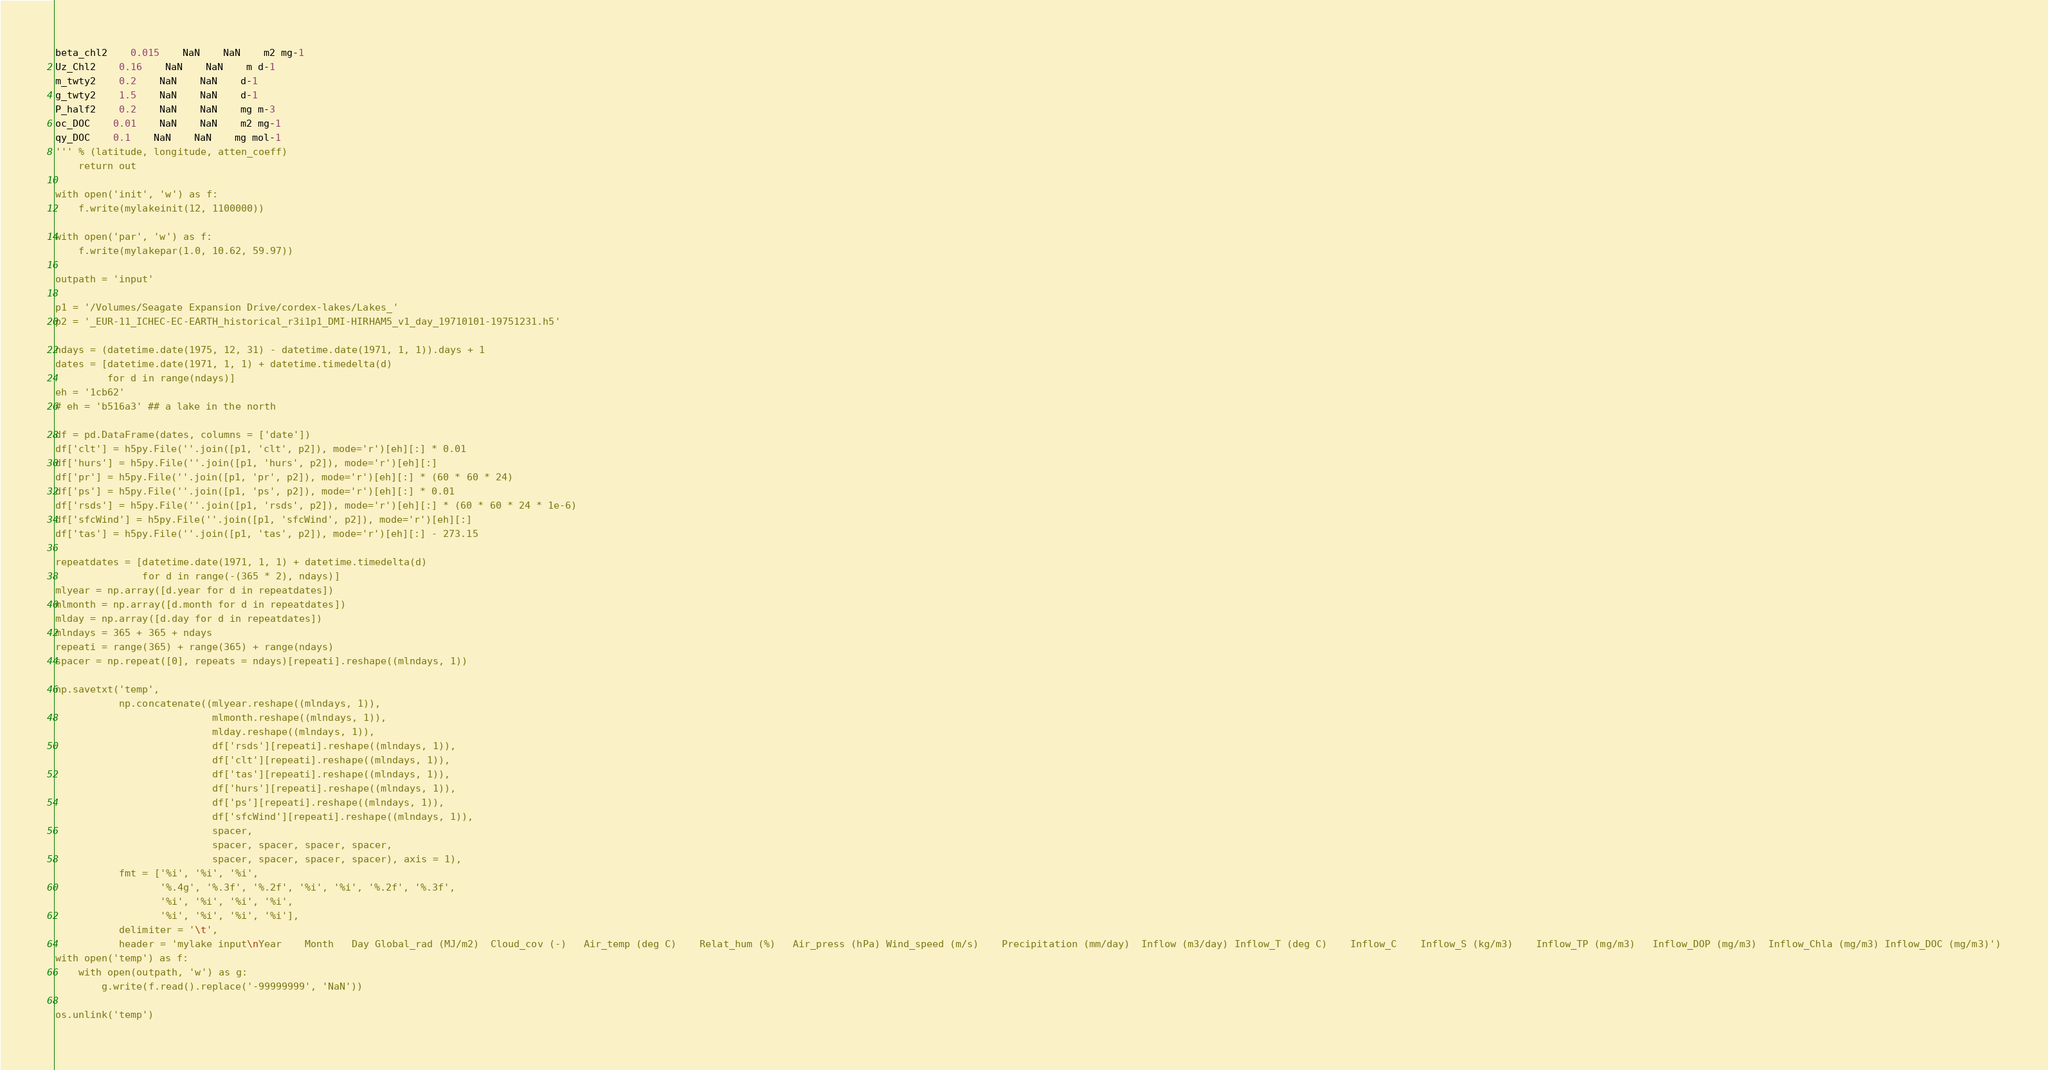Convert code to text. <code><loc_0><loc_0><loc_500><loc_500><_Python_>beta_chl2	0.015	NaN	NaN	m2 mg-1
Uz_Chl2	0.16	NaN	NaN	m d-1
m_twty2	0.2	NaN	NaN	d-1
g_twty2	1.5	NaN	NaN	d-1
P_half2	0.2	NaN	NaN	mg m-3
oc_DOC	0.01	NaN	NaN	m2 mg-1
qy_DOC	0.1	NaN	NaN	mg mol-1
''' % (latitude, longitude, atten_coeff)
    return out

with open('init', 'w') as f:
    f.write(mylakeinit(12, 1100000))

with open('par', 'w') as f:
    f.write(mylakepar(1.0, 10.62, 59.97))

outpath = 'input'

p1 = '/Volumes/Seagate Expansion Drive/cordex-lakes/Lakes_'
p2 = '_EUR-11_ICHEC-EC-EARTH_historical_r3i1p1_DMI-HIRHAM5_v1_day_19710101-19751231.h5'

ndays = (datetime.date(1975, 12, 31) - datetime.date(1971, 1, 1)).days + 1
dates = [datetime.date(1971, 1, 1) + datetime.timedelta(d) 
         for d in range(ndays)]
eh = '1cb62'
# eh = 'b516a3' ## a lake in the north

df = pd.DataFrame(dates, columns = ['date'])
df['clt'] = h5py.File(''.join([p1, 'clt', p2]), mode='r')[eh][:] * 0.01
df['hurs'] = h5py.File(''.join([p1, 'hurs', p2]), mode='r')[eh][:]
df['pr'] = h5py.File(''.join([p1, 'pr', p2]), mode='r')[eh][:] * (60 * 60 * 24)
df['ps'] = h5py.File(''.join([p1, 'ps', p2]), mode='r')[eh][:] * 0.01
df['rsds'] = h5py.File(''.join([p1, 'rsds', p2]), mode='r')[eh][:] * (60 * 60 * 24 * 1e-6)
df['sfcWind'] = h5py.File(''.join([p1, 'sfcWind', p2]), mode='r')[eh][:]
df['tas'] = h5py.File(''.join([p1, 'tas', p2]), mode='r')[eh][:] - 273.15

repeatdates = [datetime.date(1971, 1, 1) + datetime.timedelta(d) 
               for d in range(-(365 * 2), ndays)]
mlyear = np.array([d.year for d in repeatdates])
mlmonth = np.array([d.month for d in repeatdates])
mlday = np.array([d.day for d in repeatdates])
mlndays = 365 + 365 + ndays
repeati = range(365) + range(365) + range(ndays)
spacer = np.repeat([0], repeats = ndays)[repeati].reshape((mlndays, 1))

np.savetxt('temp',
           np.concatenate((mlyear.reshape((mlndays, 1)),
                           mlmonth.reshape((mlndays, 1)), 
                           mlday.reshape((mlndays, 1)), 
                           df['rsds'][repeati].reshape((mlndays, 1)),
                           df['clt'][repeati].reshape((mlndays, 1)), 
                           df['tas'][repeati].reshape((mlndays, 1)), 
                           df['hurs'][repeati].reshape((mlndays, 1)), 
                           df['ps'][repeati].reshape((mlndays, 1)), 
                           df['sfcWind'][repeati].reshape((mlndays, 1)), 
                           spacer, 
                           spacer, spacer, spacer, spacer, 
                           spacer, spacer, spacer, spacer), axis = 1), 
           fmt = ['%i', '%i', '%i', 
                  '%.4g', '%.3f', '%.2f', '%i', '%i', '%.2f', '%.3f', 
                  '%i', '%i', '%i', '%i', 
                  '%i', '%i', '%i', '%i'],
           delimiter = '\t', 
           header = 'mylake input\nYear	Month	Day	Global_rad (MJ/m2)	Cloud_cov (-)	Air_temp (deg C)	Relat_hum (%)	Air_press (hPa)	Wind_speed (m/s)	Precipitation (mm/day)	Inflow (m3/day)	Inflow_T (deg C)	Inflow_C	Inflow_S (kg/m3)	Inflow_TP (mg/m3)	Inflow_DOP (mg/m3)	Inflow_Chla (mg/m3)	Inflow_DOC (mg/m3)')
with open('temp') as f:
    with open(outpath, 'w') as g:
        g.write(f.read().replace('-99999999', 'NaN'))

os.unlink('temp')        

</code> 